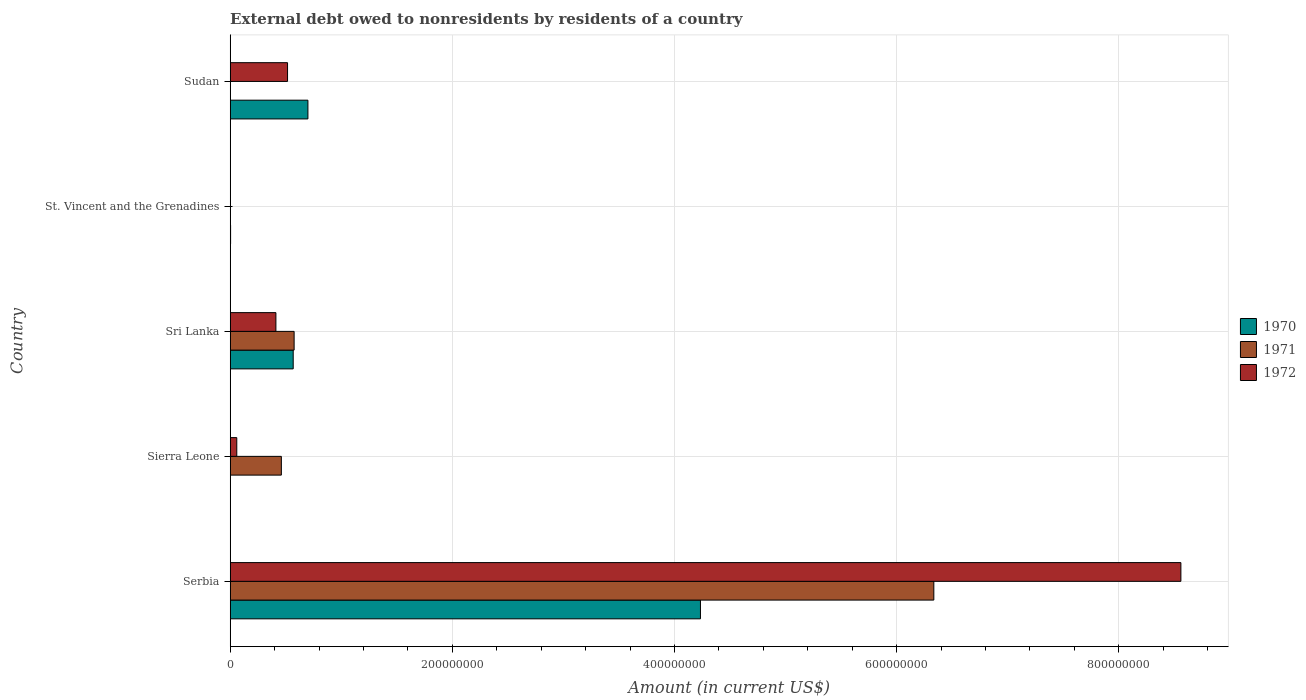How many different coloured bars are there?
Provide a succinct answer. 3. How many groups of bars are there?
Offer a terse response. 5. Are the number of bars per tick equal to the number of legend labels?
Make the answer very short. No. What is the label of the 1st group of bars from the top?
Keep it short and to the point. Sudan. What is the external debt owed by residents in 1971 in Serbia?
Your answer should be compact. 6.33e+08. Across all countries, what is the maximum external debt owed by residents in 1971?
Your answer should be compact. 6.33e+08. Across all countries, what is the minimum external debt owed by residents in 1972?
Your answer should be compact. 1.50e+04. In which country was the external debt owed by residents in 1970 maximum?
Your answer should be very brief. Serbia. What is the total external debt owed by residents in 1971 in the graph?
Provide a short and direct response. 7.37e+08. What is the difference between the external debt owed by residents in 1971 in Sierra Leone and that in St. Vincent and the Grenadines?
Offer a terse response. 4.61e+07. What is the difference between the external debt owed by residents in 1971 in Serbia and the external debt owed by residents in 1970 in Sierra Leone?
Offer a terse response. 6.33e+08. What is the average external debt owed by residents in 1971 per country?
Provide a succinct answer. 1.47e+08. What is the difference between the external debt owed by residents in 1972 and external debt owed by residents in 1971 in St. Vincent and the Grenadines?
Your answer should be compact. 1.20e+04. What is the ratio of the external debt owed by residents in 1972 in Serbia to that in Sri Lanka?
Ensure brevity in your answer.  20.8. What is the difference between the highest and the second highest external debt owed by residents in 1972?
Provide a short and direct response. 8.04e+08. What is the difference between the highest and the lowest external debt owed by residents in 1971?
Provide a succinct answer. 6.33e+08. In how many countries, is the external debt owed by residents in 1971 greater than the average external debt owed by residents in 1971 taken over all countries?
Provide a succinct answer. 1. Is it the case that in every country, the sum of the external debt owed by residents in 1971 and external debt owed by residents in 1972 is greater than the external debt owed by residents in 1970?
Provide a succinct answer. No. How many bars are there?
Your answer should be very brief. 13. How many countries are there in the graph?
Offer a very short reply. 5. Does the graph contain any zero values?
Ensure brevity in your answer.  Yes. Does the graph contain grids?
Ensure brevity in your answer.  Yes. Where does the legend appear in the graph?
Your response must be concise. Center right. How many legend labels are there?
Make the answer very short. 3. How are the legend labels stacked?
Offer a very short reply. Vertical. What is the title of the graph?
Ensure brevity in your answer.  External debt owed to nonresidents by residents of a country. Does "1979" appear as one of the legend labels in the graph?
Keep it short and to the point. No. What is the label or title of the X-axis?
Your response must be concise. Amount (in current US$). What is the Amount (in current US$) of 1970 in Serbia?
Keep it short and to the point. 4.23e+08. What is the Amount (in current US$) in 1971 in Serbia?
Ensure brevity in your answer.  6.33e+08. What is the Amount (in current US$) in 1972 in Serbia?
Keep it short and to the point. 8.56e+08. What is the Amount (in current US$) of 1971 in Sierra Leone?
Provide a succinct answer. 4.61e+07. What is the Amount (in current US$) in 1972 in Sierra Leone?
Give a very brief answer. 5.94e+06. What is the Amount (in current US$) in 1970 in Sri Lanka?
Make the answer very short. 5.67e+07. What is the Amount (in current US$) of 1971 in Sri Lanka?
Make the answer very short. 5.76e+07. What is the Amount (in current US$) in 1972 in Sri Lanka?
Keep it short and to the point. 4.12e+07. What is the Amount (in current US$) in 1971 in St. Vincent and the Grenadines?
Provide a short and direct response. 3000. What is the Amount (in current US$) in 1972 in St. Vincent and the Grenadines?
Offer a very short reply. 1.50e+04. What is the Amount (in current US$) of 1970 in Sudan?
Your response must be concise. 7.00e+07. What is the Amount (in current US$) of 1971 in Sudan?
Provide a short and direct response. 0. What is the Amount (in current US$) of 1972 in Sudan?
Offer a terse response. 5.16e+07. Across all countries, what is the maximum Amount (in current US$) of 1970?
Offer a very short reply. 4.23e+08. Across all countries, what is the maximum Amount (in current US$) of 1971?
Your answer should be compact. 6.33e+08. Across all countries, what is the maximum Amount (in current US$) of 1972?
Offer a terse response. 8.56e+08. Across all countries, what is the minimum Amount (in current US$) in 1972?
Offer a terse response. 1.50e+04. What is the total Amount (in current US$) in 1970 in the graph?
Provide a succinct answer. 5.50e+08. What is the total Amount (in current US$) in 1971 in the graph?
Your answer should be compact. 7.37e+08. What is the total Amount (in current US$) in 1972 in the graph?
Your answer should be compact. 9.55e+08. What is the difference between the Amount (in current US$) of 1971 in Serbia and that in Sierra Leone?
Your response must be concise. 5.87e+08. What is the difference between the Amount (in current US$) of 1972 in Serbia and that in Sierra Leone?
Keep it short and to the point. 8.50e+08. What is the difference between the Amount (in current US$) of 1970 in Serbia and that in Sri Lanka?
Provide a short and direct response. 3.67e+08. What is the difference between the Amount (in current US$) in 1971 in Serbia and that in Sri Lanka?
Keep it short and to the point. 5.76e+08. What is the difference between the Amount (in current US$) in 1972 in Serbia and that in Sri Lanka?
Offer a very short reply. 8.15e+08. What is the difference between the Amount (in current US$) of 1970 in Serbia and that in St. Vincent and the Grenadines?
Offer a very short reply. 4.23e+08. What is the difference between the Amount (in current US$) of 1971 in Serbia and that in St. Vincent and the Grenadines?
Offer a terse response. 6.33e+08. What is the difference between the Amount (in current US$) of 1972 in Serbia and that in St. Vincent and the Grenadines?
Provide a succinct answer. 8.56e+08. What is the difference between the Amount (in current US$) in 1970 in Serbia and that in Sudan?
Your answer should be very brief. 3.53e+08. What is the difference between the Amount (in current US$) of 1972 in Serbia and that in Sudan?
Provide a succinct answer. 8.04e+08. What is the difference between the Amount (in current US$) of 1971 in Sierra Leone and that in Sri Lanka?
Keep it short and to the point. -1.15e+07. What is the difference between the Amount (in current US$) of 1972 in Sierra Leone and that in Sri Lanka?
Your answer should be very brief. -3.52e+07. What is the difference between the Amount (in current US$) in 1971 in Sierra Leone and that in St. Vincent and the Grenadines?
Ensure brevity in your answer.  4.61e+07. What is the difference between the Amount (in current US$) in 1972 in Sierra Leone and that in St. Vincent and the Grenadines?
Offer a very short reply. 5.92e+06. What is the difference between the Amount (in current US$) in 1972 in Sierra Leone and that in Sudan?
Keep it short and to the point. -4.57e+07. What is the difference between the Amount (in current US$) of 1970 in Sri Lanka and that in St. Vincent and the Grenadines?
Provide a succinct answer. 5.64e+07. What is the difference between the Amount (in current US$) of 1971 in Sri Lanka and that in St. Vincent and the Grenadines?
Give a very brief answer. 5.76e+07. What is the difference between the Amount (in current US$) of 1972 in Sri Lanka and that in St. Vincent and the Grenadines?
Make the answer very short. 4.11e+07. What is the difference between the Amount (in current US$) of 1970 in Sri Lanka and that in Sudan?
Your answer should be compact. -1.32e+07. What is the difference between the Amount (in current US$) of 1972 in Sri Lanka and that in Sudan?
Provide a short and direct response. -1.05e+07. What is the difference between the Amount (in current US$) of 1970 in St. Vincent and the Grenadines and that in Sudan?
Make the answer very short. -6.96e+07. What is the difference between the Amount (in current US$) in 1972 in St. Vincent and the Grenadines and that in Sudan?
Your answer should be very brief. -5.16e+07. What is the difference between the Amount (in current US$) in 1970 in Serbia and the Amount (in current US$) in 1971 in Sierra Leone?
Your response must be concise. 3.77e+08. What is the difference between the Amount (in current US$) of 1970 in Serbia and the Amount (in current US$) of 1972 in Sierra Leone?
Keep it short and to the point. 4.17e+08. What is the difference between the Amount (in current US$) of 1971 in Serbia and the Amount (in current US$) of 1972 in Sierra Leone?
Make the answer very short. 6.28e+08. What is the difference between the Amount (in current US$) of 1970 in Serbia and the Amount (in current US$) of 1971 in Sri Lanka?
Provide a short and direct response. 3.66e+08. What is the difference between the Amount (in current US$) in 1970 in Serbia and the Amount (in current US$) in 1972 in Sri Lanka?
Offer a very short reply. 3.82e+08. What is the difference between the Amount (in current US$) of 1971 in Serbia and the Amount (in current US$) of 1972 in Sri Lanka?
Your answer should be compact. 5.92e+08. What is the difference between the Amount (in current US$) of 1970 in Serbia and the Amount (in current US$) of 1971 in St. Vincent and the Grenadines?
Provide a short and direct response. 4.23e+08. What is the difference between the Amount (in current US$) in 1970 in Serbia and the Amount (in current US$) in 1972 in St. Vincent and the Grenadines?
Offer a terse response. 4.23e+08. What is the difference between the Amount (in current US$) in 1971 in Serbia and the Amount (in current US$) in 1972 in St. Vincent and the Grenadines?
Make the answer very short. 6.33e+08. What is the difference between the Amount (in current US$) of 1970 in Serbia and the Amount (in current US$) of 1972 in Sudan?
Keep it short and to the point. 3.72e+08. What is the difference between the Amount (in current US$) of 1971 in Serbia and the Amount (in current US$) of 1972 in Sudan?
Ensure brevity in your answer.  5.82e+08. What is the difference between the Amount (in current US$) of 1971 in Sierra Leone and the Amount (in current US$) of 1972 in Sri Lanka?
Make the answer very short. 4.91e+06. What is the difference between the Amount (in current US$) in 1971 in Sierra Leone and the Amount (in current US$) in 1972 in St. Vincent and the Grenadines?
Provide a succinct answer. 4.60e+07. What is the difference between the Amount (in current US$) in 1971 in Sierra Leone and the Amount (in current US$) in 1972 in Sudan?
Give a very brief answer. -5.58e+06. What is the difference between the Amount (in current US$) in 1970 in Sri Lanka and the Amount (in current US$) in 1971 in St. Vincent and the Grenadines?
Your response must be concise. 5.67e+07. What is the difference between the Amount (in current US$) in 1970 in Sri Lanka and the Amount (in current US$) in 1972 in St. Vincent and the Grenadines?
Give a very brief answer. 5.67e+07. What is the difference between the Amount (in current US$) in 1971 in Sri Lanka and the Amount (in current US$) in 1972 in St. Vincent and the Grenadines?
Your response must be concise. 5.75e+07. What is the difference between the Amount (in current US$) in 1970 in Sri Lanka and the Amount (in current US$) in 1972 in Sudan?
Your answer should be compact. 5.09e+06. What is the difference between the Amount (in current US$) of 1971 in Sri Lanka and the Amount (in current US$) of 1972 in Sudan?
Provide a succinct answer. 5.91e+06. What is the difference between the Amount (in current US$) in 1970 in St. Vincent and the Grenadines and the Amount (in current US$) in 1972 in Sudan?
Your answer should be very brief. -5.13e+07. What is the difference between the Amount (in current US$) of 1971 in St. Vincent and the Grenadines and the Amount (in current US$) of 1972 in Sudan?
Keep it short and to the point. -5.16e+07. What is the average Amount (in current US$) in 1970 per country?
Keep it short and to the point. 1.10e+08. What is the average Amount (in current US$) in 1971 per country?
Your response must be concise. 1.47e+08. What is the average Amount (in current US$) of 1972 per country?
Provide a short and direct response. 1.91e+08. What is the difference between the Amount (in current US$) of 1970 and Amount (in current US$) of 1971 in Serbia?
Make the answer very short. -2.10e+08. What is the difference between the Amount (in current US$) in 1970 and Amount (in current US$) in 1972 in Serbia?
Your response must be concise. -4.32e+08. What is the difference between the Amount (in current US$) of 1971 and Amount (in current US$) of 1972 in Serbia?
Keep it short and to the point. -2.22e+08. What is the difference between the Amount (in current US$) in 1971 and Amount (in current US$) in 1972 in Sierra Leone?
Ensure brevity in your answer.  4.01e+07. What is the difference between the Amount (in current US$) in 1970 and Amount (in current US$) in 1971 in Sri Lanka?
Offer a terse response. -8.21e+05. What is the difference between the Amount (in current US$) in 1970 and Amount (in current US$) in 1972 in Sri Lanka?
Offer a very short reply. 1.56e+07. What is the difference between the Amount (in current US$) in 1971 and Amount (in current US$) in 1972 in Sri Lanka?
Give a very brief answer. 1.64e+07. What is the difference between the Amount (in current US$) in 1970 and Amount (in current US$) in 1971 in St. Vincent and the Grenadines?
Your answer should be compact. 3.57e+05. What is the difference between the Amount (in current US$) of 1970 and Amount (in current US$) of 1972 in St. Vincent and the Grenadines?
Your answer should be very brief. 3.45e+05. What is the difference between the Amount (in current US$) in 1971 and Amount (in current US$) in 1972 in St. Vincent and the Grenadines?
Give a very brief answer. -1.20e+04. What is the difference between the Amount (in current US$) in 1970 and Amount (in current US$) in 1972 in Sudan?
Offer a terse response. 1.83e+07. What is the ratio of the Amount (in current US$) of 1971 in Serbia to that in Sierra Leone?
Make the answer very short. 13.75. What is the ratio of the Amount (in current US$) in 1972 in Serbia to that in Sierra Leone?
Make the answer very short. 144.15. What is the ratio of the Amount (in current US$) in 1970 in Serbia to that in Sri Lanka?
Your response must be concise. 7.46. What is the ratio of the Amount (in current US$) in 1971 in Serbia to that in Sri Lanka?
Offer a terse response. 11.01. What is the ratio of the Amount (in current US$) of 1972 in Serbia to that in Sri Lanka?
Your answer should be compact. 20.8. What is the ratio of the Amount (in current US$) of 1970 in Serbia to that in St. Vincent and the Grenadines?
Ensure brevity in your answer.  1175.96. What is the ratio of the Amount (in current US$) of 1971 in Serbia to that in St. Vincent and the Grenadines?
Give a very brief answer. 2.11e+05. What is the ratio of the Amount (in current US$) in 1972 in Serbia to that in St. Vincent and the Grenadines?
Your answer should be very brief. 5.71e+04. What is the ratio of the Amount (in current US$) of 1970 in Serbia to that in Sudan?
Your response must be concise. 6.05. What is the ratio of the Amount (in current US$) of 1972 in Serbia to that in Sudan?
Provide a succinct answer. 16.57. What is the ratio of the Amount (in current US$) of 1971 in Sierra Leone to that in Sri Lanka?
Make the answer very short. 0.8. What is the ratio of the Amount (in current US$) of 1972 in Sierra Leone to that in Sri Lanka?
Keep it short and to the point. 0.14. What is the ratio of the Amount (in current US$) in 1971 in Sierra Leone to that in St. Vincent and the Grenadines?
Offer a very short reply. 1.54e+04. What is the ratio of the Amount (in current US$) of 1972 in Sierra Leone to that in St. Vincent and the Grenadines?
Ensure brevity in your answer.  395.8. What is the ratio of the Amount (in current US$) of 1972 in Sierra Leone to that in Sudan?
Keep it short and to the point. 0.12. What is the ratio of the Amount (in current US$) in 1970 in Sri Lanka to that in St. Vincent and the Grenadines?
Give a very brief answer. 157.59. What is the ratio of the Amount (in current US$) of 1971 in Sri Lanka to that in St. Vincent and the Grenadines?
Offer a terse response. 1.92e+04. What is the ratio of the Amount (in current US$) in 1972 in Sri Lanka to that in St. Vincent and the Grenadines?
Ensure brevity in your answer.  2743.4. What is the ratio of the Amount (in current US$) in 1970 in Sri Lanka to that in Sudan?
Your answer should be very brief. 0.81. What is the ratio of the Amount (in current US$) in 1972 in Sri Lanka to that in Sudan?
Offer a terse response. 0.8. What is the ratio of the Amount (in current US$) in 1970 in St. Vincent and the Grenadines to that in Sudan?
Offer a terse response. 0.01. What is the difference between the highest and the second highest Amount (in current US$) in 1970?
Keep it short and to the point. 3.53e+08. What is the difference between the highest and the second highest Amount (in current US$) of 1971?
Offer a very short reply. 5.76e+08. What is the difference between the highest and the second highest Amount (in current US$) of 1972?
Your response must be concise. 8.04e+08. What is the difference between the highest and the lowest Amount (in current US$) of 1970?
Your response must be concise. 4.23e+08. What is the difference between the highest and the lowest Amount (in current US$) of 1971?
Your answer should be very brief. 6.33e+08. What is the difference between the highest and the lowest Amount (in current US$) of 1972?
Offer a very short reply. 8.56e+08. 